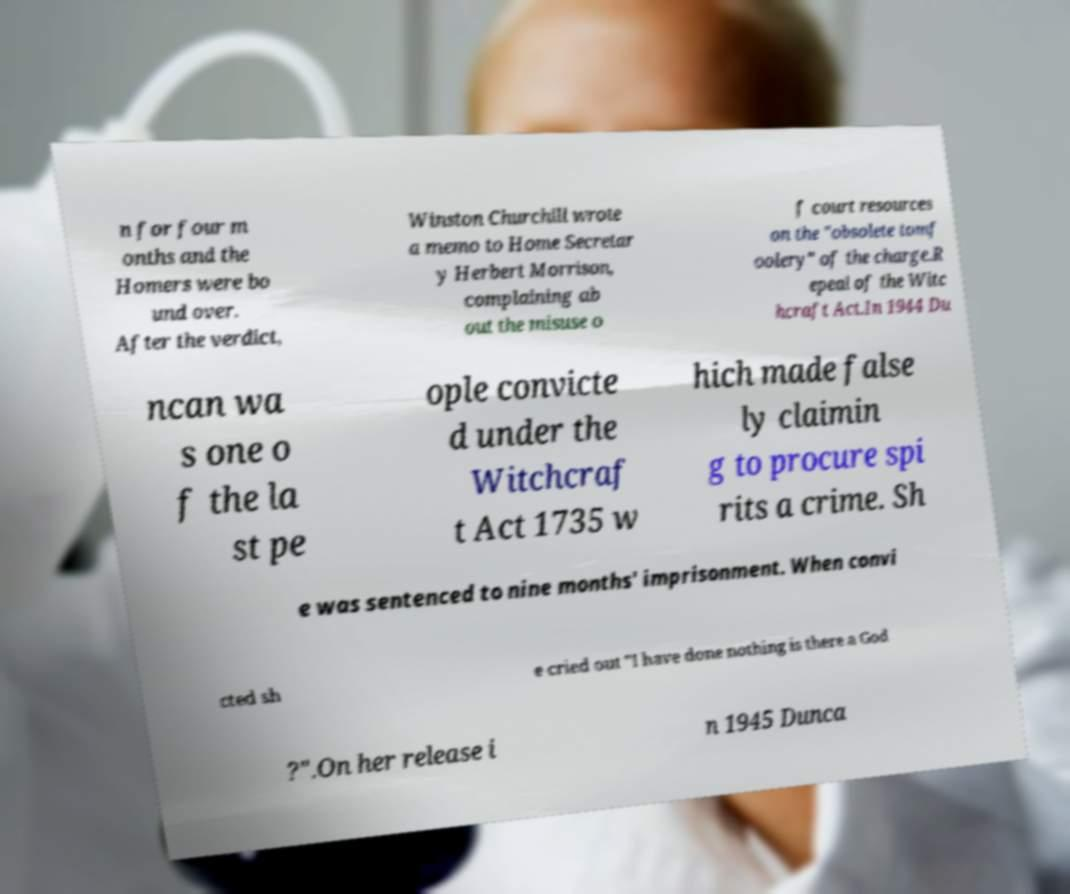Could you extract and type out the text from this image? n for four m onths and the Homers were bo und over. After the verdict, Winston Churchill wrote a memo to Home Secretar y Herbert Morrison, complaining ab out the misuse o f court resources on the "obsolete tomf oolery" of the charge.R epeal of the Witc hcraft Act.In 1944 Du ncan wa s one o f the la st pe ople convicte d under the Witchcraf t Act 1735 w hich made false ly claimin g to procure spi rits a crime. Sh e was sentenced to nine months' imprisonment. When convi cted sh e cried out "I have done nothing is there a God ?".On her release i n 1945 Dunca 